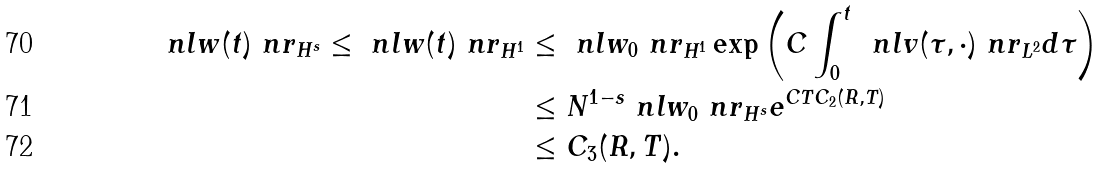<formula> <loc_0><loc_0><loc_500><loc_500>\ n l w ( t ) \ n r _ { H ^ { s } } \leq \ n l w ( t ) \ n r _ { H ^ { 1 } } & \leq \ n l w _ { 0 } \ n r _ { H ^ { 1 } } \exp \left ( C \int _ { 0 } ^ { t } \, \ n l v ( \tau , \cdot ) \ n r _ { L ^ { 2 } } d \tau \right ) \\ & \leq N ^ { 1 - s } \ n l w _ { 0 } \ n r _ { H ^ { s } } e ^ { C T C _ { 2 } ( R , T ) } \\ & \leq C _ { 3 } ( R , T ) .</formula> 